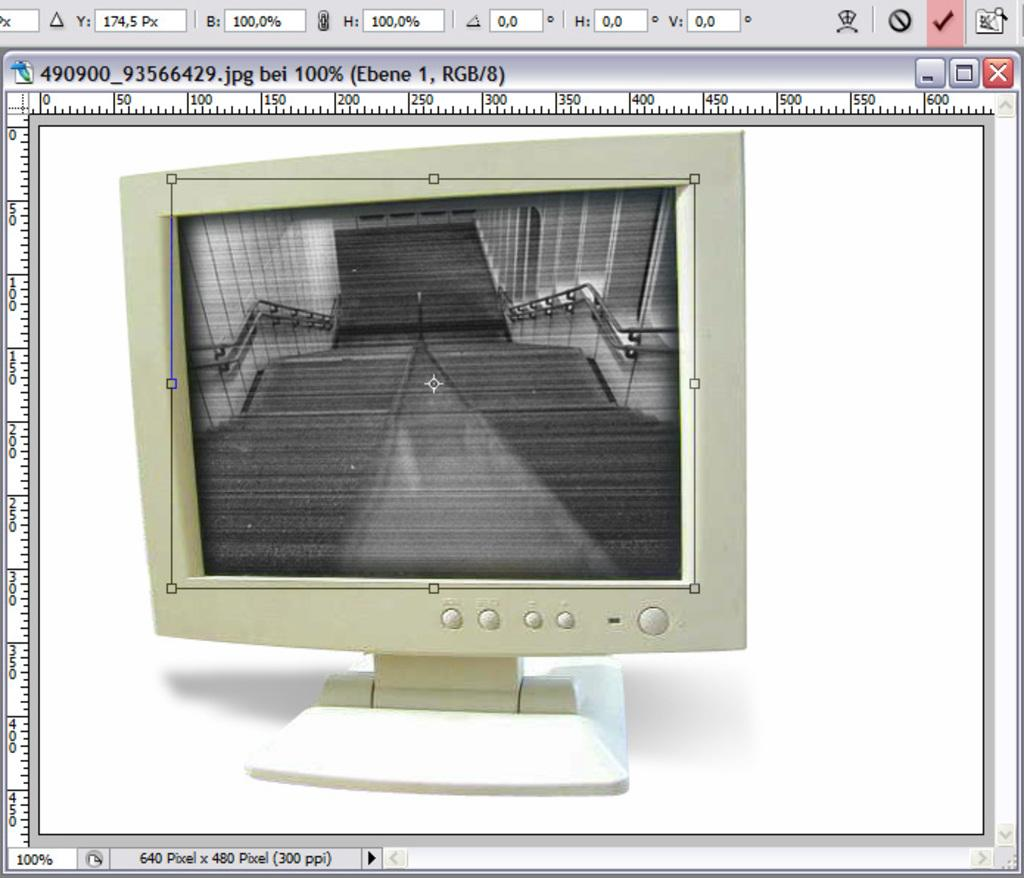<image>
Offer a succinct explanation of the picture presented. A photo of a computer Monitor that says it is 640 Pixel x 400 Pixels. 